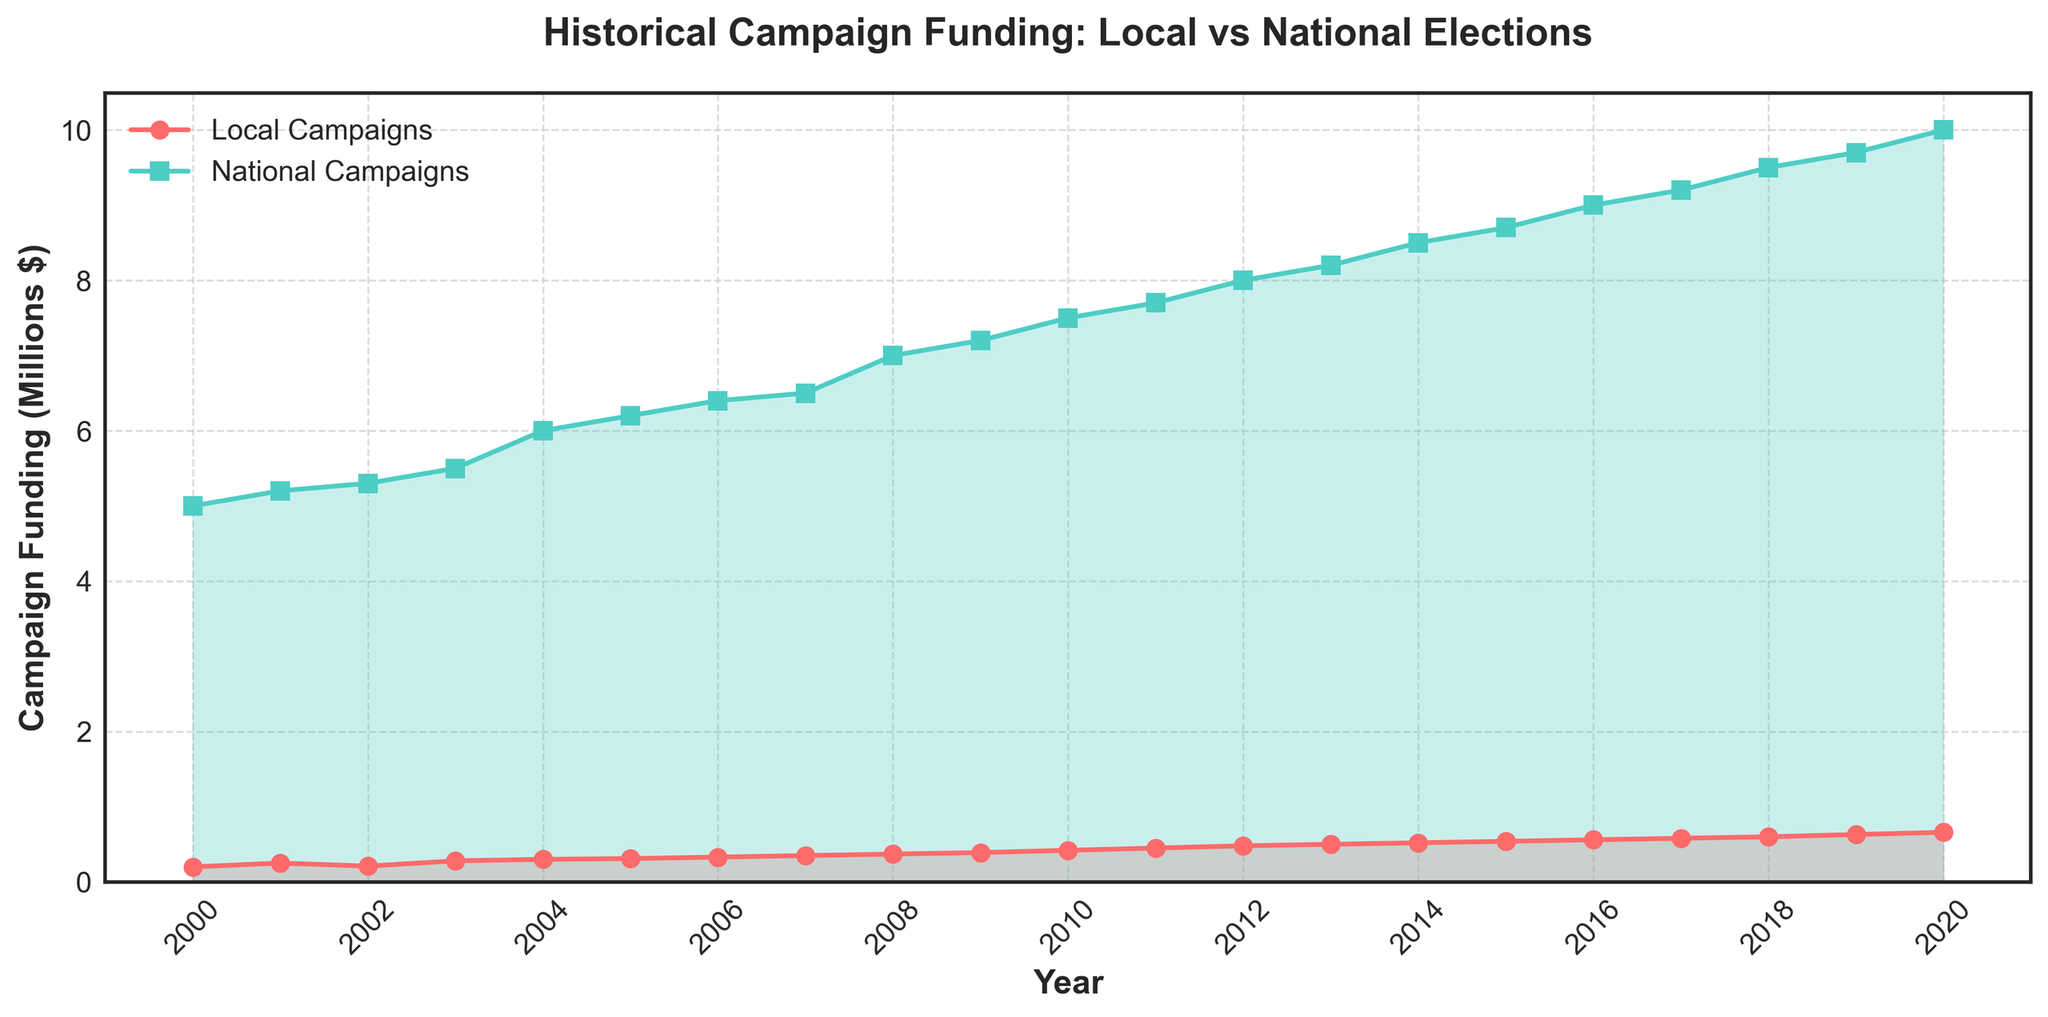What is the title of the plot? The title is prominently displayed at the top of the plot, providing a summary description of what the plot represents.
Answer: Historical Campaign Funding: Local vs National Elections Which axis represents the years? Observing the plot, the horizontal (x-axis) lists the years from 2000 to 2020.
Answer: The x-axis What is the color of the line representing local campaign funding? The line for local campaign funding is marked in a specific color throughout the plot.
Answer: Red In which year does national campaign funding exceed $9 million? By observing the y-axis and following the national funding line to where it crosses $9 million, you can identify the correct year.
Answer: 2016 Which campaign type sees more funding in the year 2020? To answer this, compare the ending points of both lines for the year 2020 on the x-axis.
Answer: National Campaigns What is the difference in campaign funding between local and national campaigns in 2004? Subtract the local campaign funding value from the national campaign funding value for 2004: $6,000,000 - $300,000 = $5,700,000
Answer: $5,700,000 How has local campaign funding changed from 2000 to 2020? The plot shows a trend, with funding for local campaigns starting at $200,000 in 2000 and increasing to $660,000 in 2020.
Answer: Increased How many data points are there in the plot for national campaign funding? Count the number of markers (squares) depicting national campaign funding from the year 2000 to 2020.
Answer: 21 By how much did national campaign funding increase from 2008 to 2009? Subtract the 2008 value from the 2009 value for national campaign funding: $7,200,000 - $7,000,000 = $200,000
Answer: $200,000 What’s the average annual funding for local campaigns over the years 2008 to 2012? Add the local campaign funding values from 2008 to 2012 and divide by the number of years (5): ($370,000 + $390,000 + $420,000 + $450,000 + $480,000)/5
Answer: $422,000 